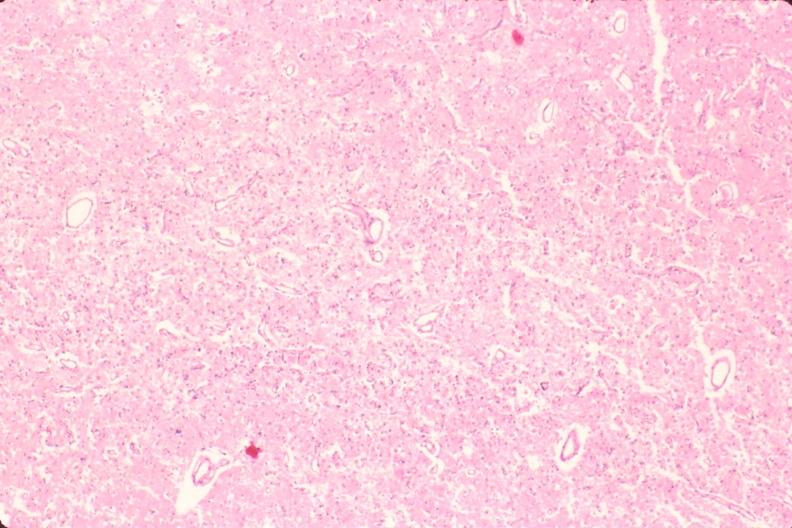does this image show brain, old infarcts, embolic?
Answer the question using a single word or phrase. Yes 